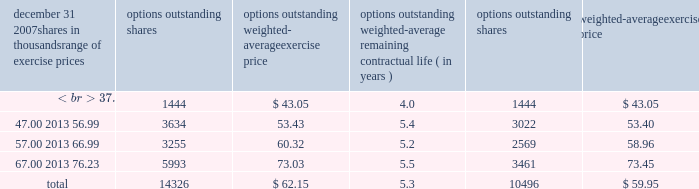Information about stock options at december 31 , 2007 follows: .
( a ) the weighted-average remaining contractual life was approximately 4.2 years .
At december 31 , 2007 , there were approximately 13788000 options in total that were vested and are expected to vest .
The weighted-average exercise price of such options was $ 62.07 per share , the weighted-average remaining contractual life was approximately 5.2 years , and the aggregate intrinsic value at december 31 , 2007 was approximately $ 92 million .
Stock options granted in 2005 include options for 30000 shares that were granted to non-employee directors that year .
No such options were granted in 2006 or 2007 .
Awards granted to non-employee directors in 2007 include 20944 deferred stock units awarded under the outside directors deferred stock unit plan .
A deferred stock unit is a phantom share of our common stock , which requires liability accounting treatment under sfas 123r until such awards are paid to the participants as cash .
As there are no vestings or service requirements on these awards , total compensation expense is recognized in full on all awarded units on the date of grant .
The weighted-average grant-date fair value of options granted in 2007 , 2006 and 2005 was $ 11.37 , $ 10.75 and $ 9.83 per option , respectively .
To determine stock-based compensation expense under sfas 123r , the grant-date fair value is applied to the options granted with a reduction made for estimated forfeitures .
At december 31 , 2006 and 2005 options for 10743000 and 13582000 shares of common stock , respectively , were exercisable at a weighted-average price of $ 58.38 and $ 56.58 , respectively .
The total intrinsic value of options exercised during 2007 , 2006 and 2005 was $ 52 million , $ 111 million and $ 31 million , respectively .
At december 31 , 2007 the aggregate intrinsic value of all options outstanding and exercisable was $ 94 million and $ 87 million , respectively .
Cash received from option exercises under all incentive plans for 2007 , 2006 and 2005 was approximately $ 111 million , $ 233 million and $ 98 million , respectively .
The actual tax benefit realized for tax deduction purposes from option exercises under all incentive plans for 2007 , 2006 and 2005 was approximately $ 39 million , $ 82 million and $ 34 million , respectively .
There were no options granted in excess of market value in 2007 , 2006 or 2005 .
Shares of common stock available during the next year for the granting of options and other awards under the incentive plans were 40116726 at december 31 , 2007 .
Total shares of pnc common stock authorized for future issuance under equity compensation plans totaled 41787400 shares at december 31 , 2007 , which includes shares available for issuance under the incentive plans , the employee stock purchase plan as described below , and a director plan .
During 2007 , we issued approximately 2.1 million shares from treasury stock in connection with stock option exercise activity .
As with past exercise activity , we intend to utilize treasury stock for future stock option exercises .
As discussed in note 1 accounting policies , we adopted the fair value recognition provisions of sfas 123 prospectively to all employee awards including stock options granted , modified or settled after january 1 , 2003 .
As permitted under sfas 123 , we recognized compensation expense for stock options on a straight-line basis over the pro rata vesting period .
Total compensation expense recognized related to pnc stock options in 2007 was $ 29 million compared with $ 31 million in 2006 and $ 29 million in 2005 .
Pro forma effects a table is included in note 1 accounting policies that sets forth pro forma net income and basic and diluted earnings per share as if compensation expense had been recognized under sfas 123 and 123r , as amended , for stock options for 2005 .
For purposes of computing stock option expense and 2005 pro forma results , we estimated the fair value of stock options using the black-scholes option pricing model .
The model requires the use of numerous assumptions , many of which are very subjective .
Therefore , the 2005 pro forma results are estimates of results of operations as if compensation expense had been recognized for all stock-based compensation awards and are not indicative of the impact on future periods. .
What was the total intrinsic value of options exercised during 2007 , 2006 and 2005 in millions? 
Computations: ((52 + 111) + 31)
Answer: 194.0. 